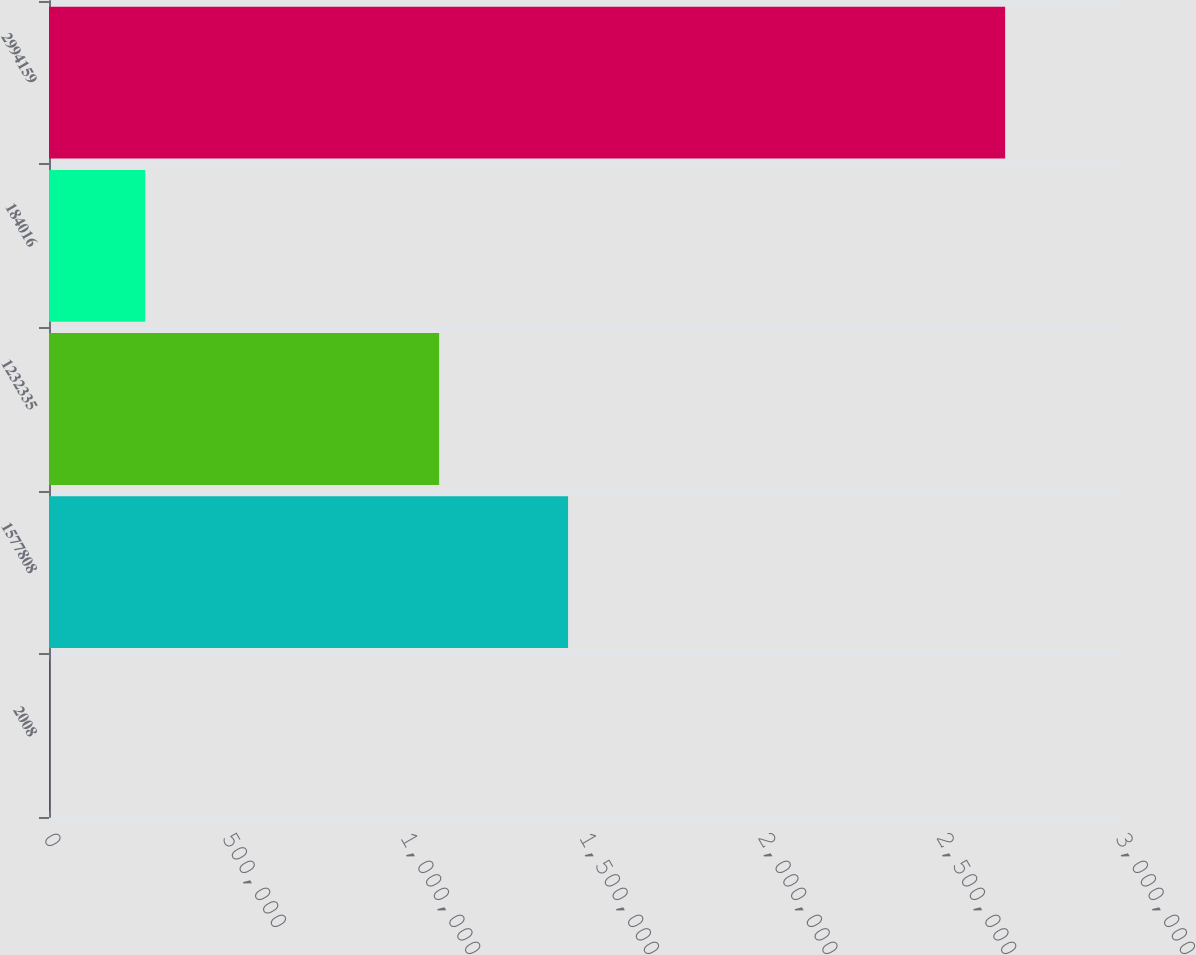Convert chart. <chart><loc_0><loc_0><loc_500><loc_500><bar_chart><fcel>2008<fcel>1577808<fcel>1232335<fcel>184016<fcel>2994159<nl><fcel>2007<fcel>1.45262e+06<fcel>1.09183e+06<fcel>269380<fcel>2.67573e+06<nl></chart> 